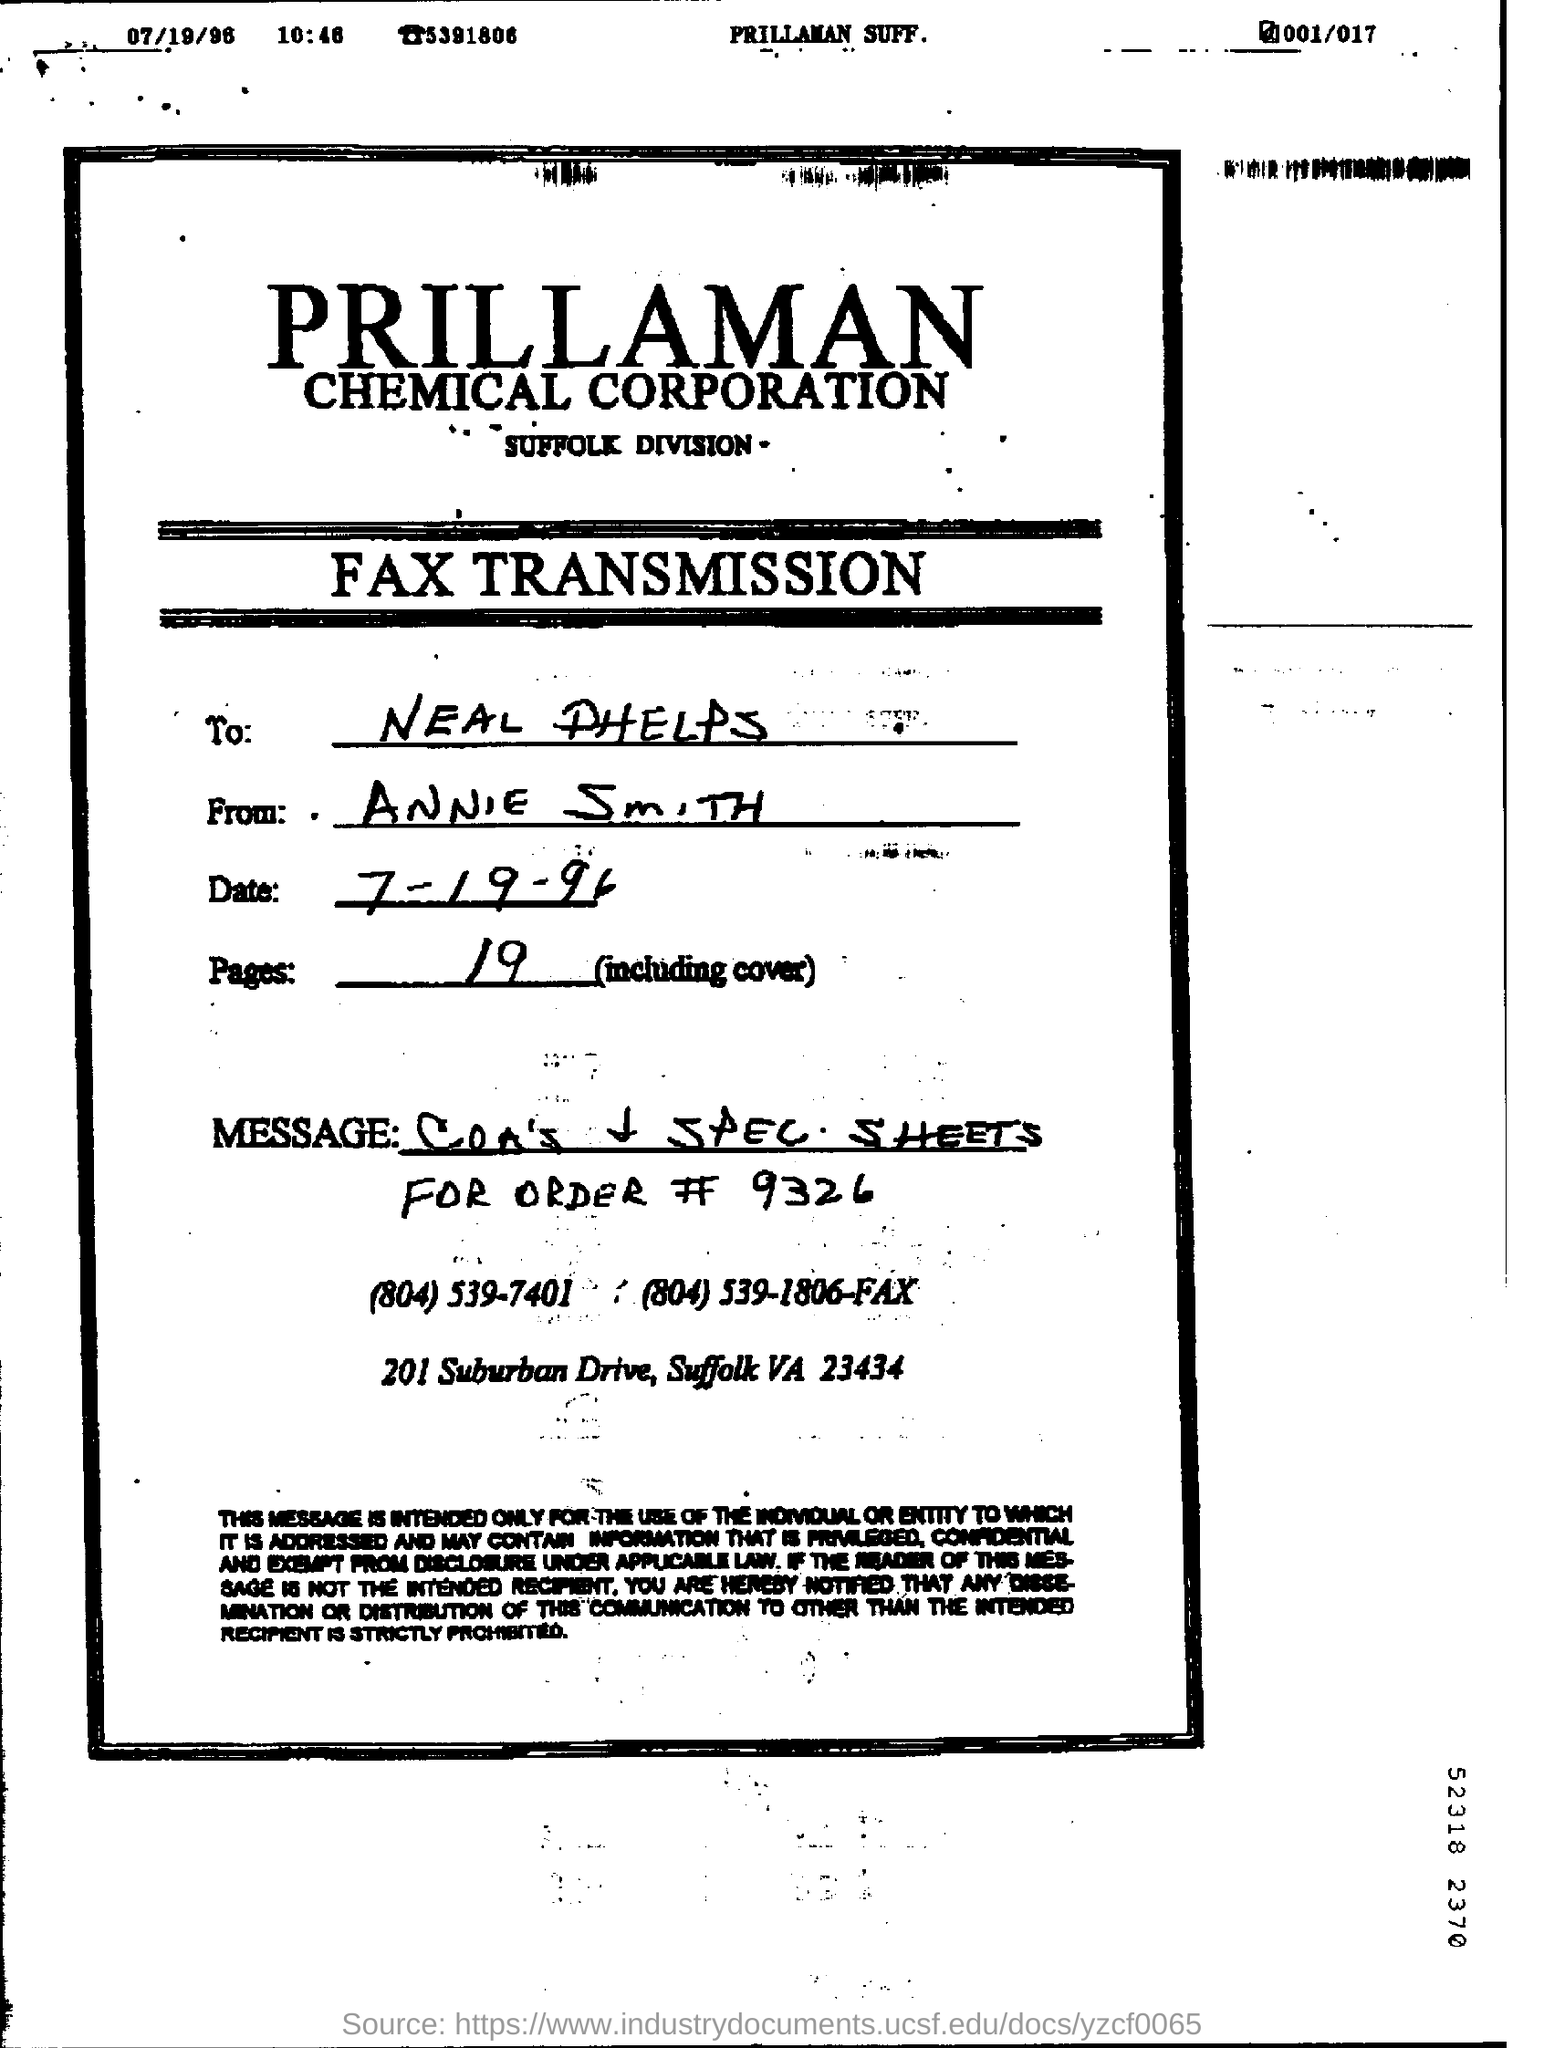Who is the sender of the letter?
Your answer should be compact. ANNIE SMITH. 